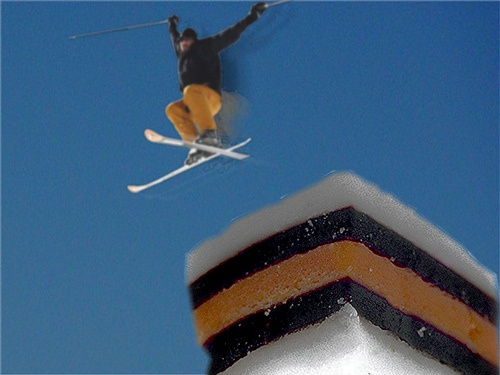Describe the objects in this image and their specific colors. I can see people in gray, black, brown, and blue tones and skis in gray, darkgray, lightgray, and blue tones in this image. 